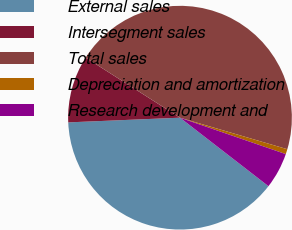Convert chart. <chart><loc_0><loc_0><loc_500><loc_500><pie_chart><fcel>External sales<fcel>Intersegment sales<fcel>Total sales<fcel>Depreciation and amortization<fcel>Research development and<nl><fcel>38.85%<fcel>9.69%<fcel>45.53%<fcel>0.73%<fcel>5.21%<nl></chart> 